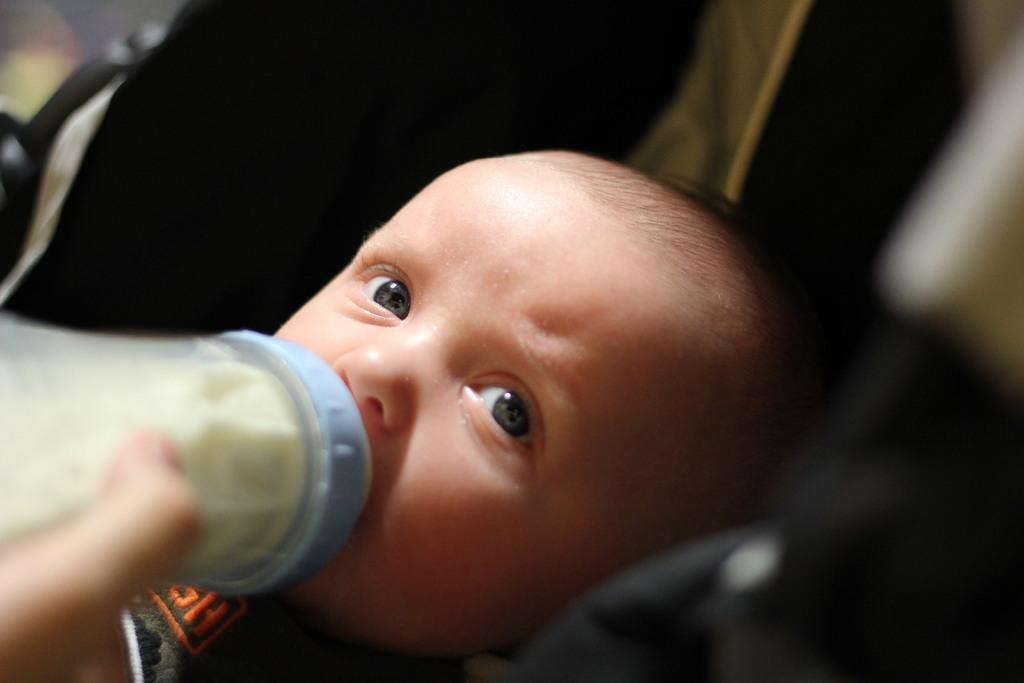What is the main subject of the image? There is a small baby in the image. What is the baby doing in the image? The baby is drinking milk from a bottle. What is the baby's facial expression or gaze in the image? The baby is looking at the camera. What can be observed about the background of the image? There is a dark background in the image. What hobbies does the baby have, as depicted in the image? The image does not provide information about the baby's hobbies; it only shows the baby drinking milk from a bottle. How many plates are visible in the image? There are no plates visible in the image. 